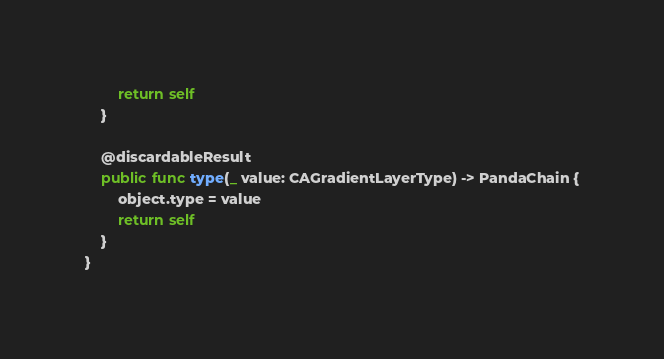Convert code to text. <code><loc_0><loc_0><loc_500><loc_500><_Swift_>        return self
    }

    @discardableResult
    public func type(_ value: CAGradientLayerType) -> PandaChain {
        object.type = value
        return self
    }
}
</code> 